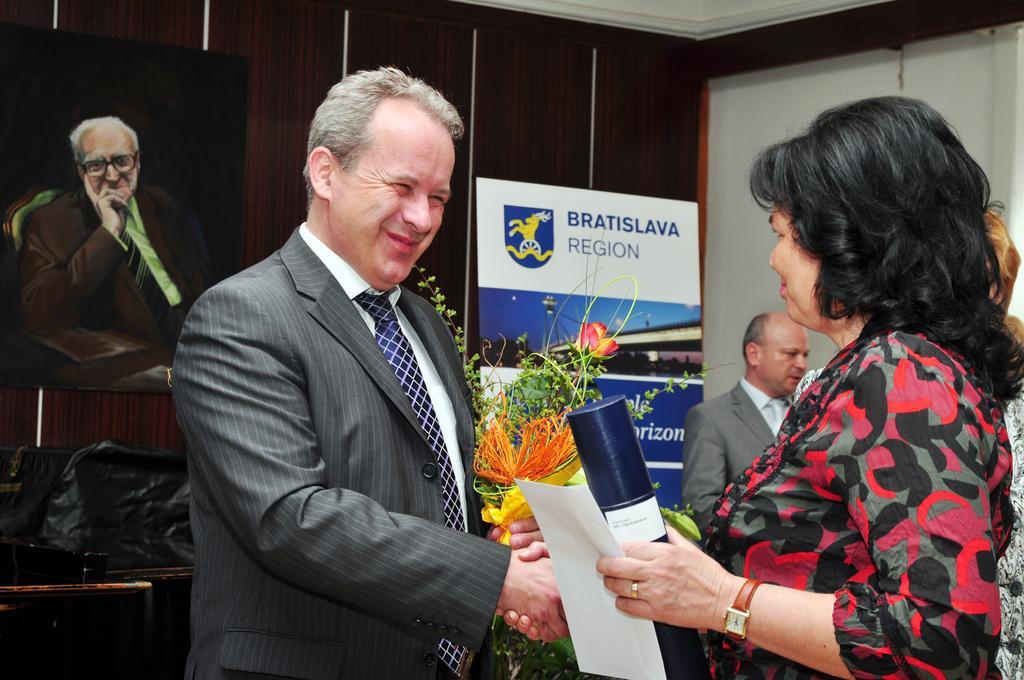Describe this image in one or two sentences. There is a man in suit, standing, smiling and shaking hand with a woman who is holding a bottle and a paper with other hand. In the background, there is a hoarding, near a plant and a person standing, there is a painting on the wooden wall, there is white wall and white color roof. 